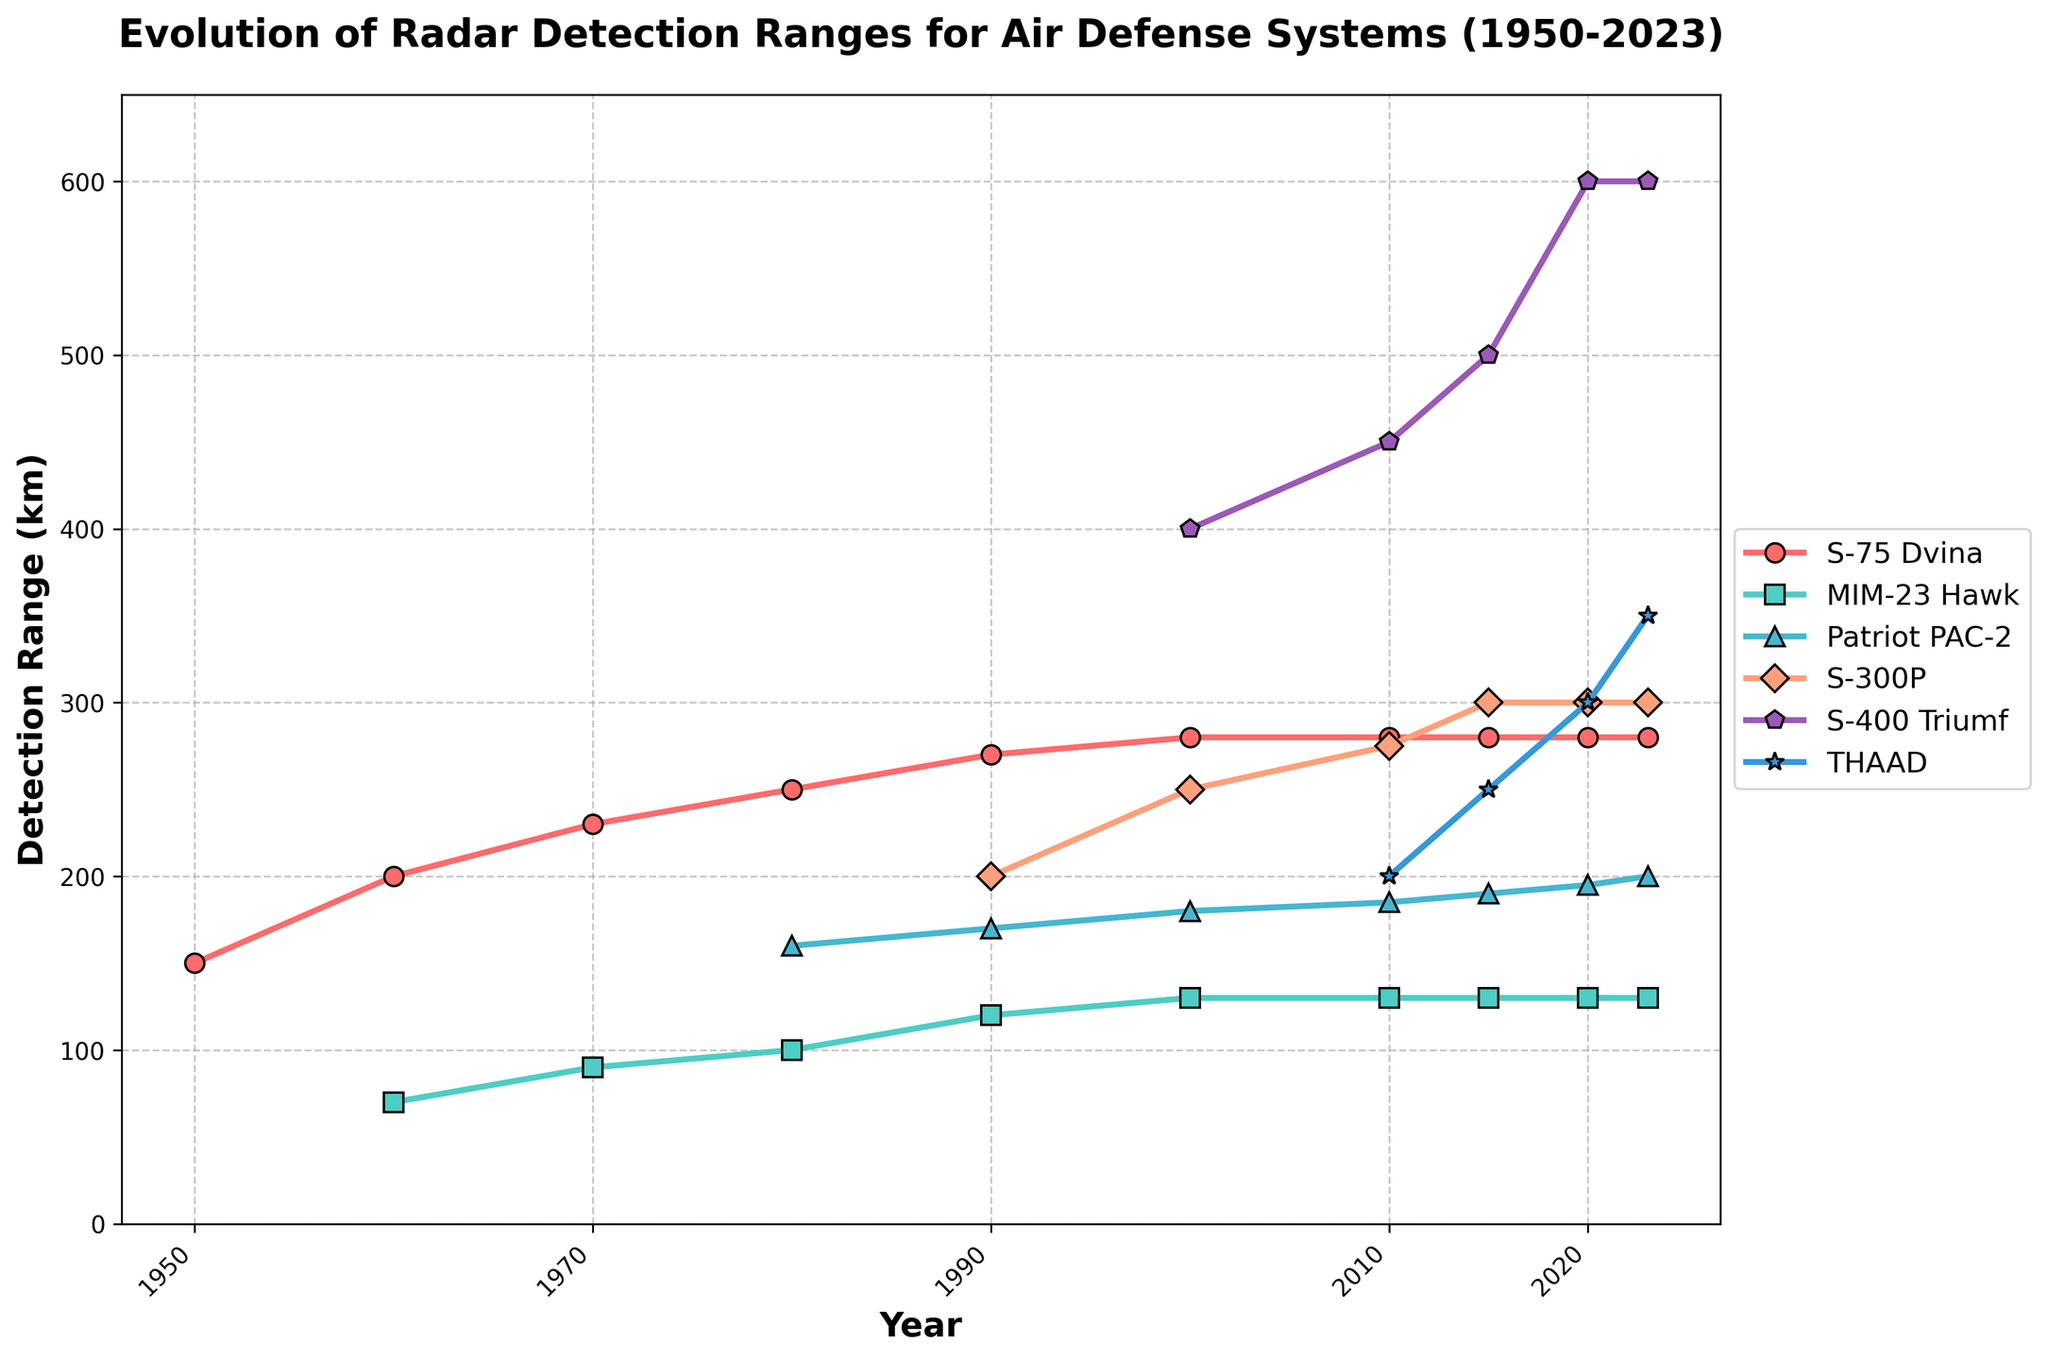What is the detection range of the S-400 Triumf in 2023? The detection range of the S-400 Triumf in 2023 can be directly read from the figure as the data point corresponding to the year 2023.
Answer: 600 km Which air defense system shows the greatest increase in detection range between 1950 and 2023? To find the greatest increase, subtract the detection range in 1950 from the detection range in 2023 for each system and compare the differences. S-75 Dvina: 280 - 150 = 130. MIM-23 Hawk: 130 - 70 = 60. S-300P: 300 - 200 = 100. S-400 Triumf: 600 - 0 = 600. THAAD: 350 - 0 = 350. The S-400 Triumf shows the largest increase.
Answer: S-400 Triumf Which year did the THAAD system first appear in the data? The first appearance of THAAD in the data can be identified by looking at the year it first has a non-zero detection range. From the chart, this appears in the year 2000.
Answer: 2000 Which system had the smallest detection range in 1990? To determine the smallest detection range in 1990, compare the values of each system in that year. S-75 Dvina: 270 km, MIM-23 Hawk: 120 km, Patriot PAC-2: 170 km, S-300P: 200 km. MIM-23 Hawk has the smallest range.
Answer: MIM-23 Hawk How many air defense systems have detection ranges exceeding 200 km in 2023? Check each system's detection range in 2023 to see how many are above 200 km. S-75 Dvina: 280 km, MIM-23 Hawk: 130 km, Patriot PAC-2: 200 km, S-300P: 300 km, S-400 Triumf: 600 km, THAAD: 350 km. Four systems exceed 200 km.
Answer: 4 What is the average detection range of the Patriot PAC-2 system from 1980 to 2023? Sum the detection ranges of Patriot PAC-2 from 1980, 1990, 2000, 2010, 2015, 2020, and 2023 and divide by the number of instances. (160 + 170 + 180 + 185 + 190 + 195 + 200)/7 = 182
Answer: 182 km Which detection ranges remain unchanged between 2000 and 2023? Compare the detection range values for each system in 2000 and 2023. Systems with unchanged values will have the same range values in both years. S-75 Dvina: 280 km in both. MIM-23 Hawk: 130 km in both.
Answer: S-75 Dvina and MIM-23 Hawk In what year did the S-75 Dvina first exceed a detection range of 200 km? Look at the data points for the S-75 Dvina until the detection range first exceeds 200 km. The first year this happens is 1970 when the range reaches 230 km.
Answer: 1970 Which year marks the introduction of the S-400 Triumf in the data? The S-400 Triumf appears in the data starting in the year 2000, which is visible as its range data first entering the chart.
Answer: 2000 